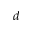<formula> <loc_0><loc_0><loc_500><loc_500>d</formula> 